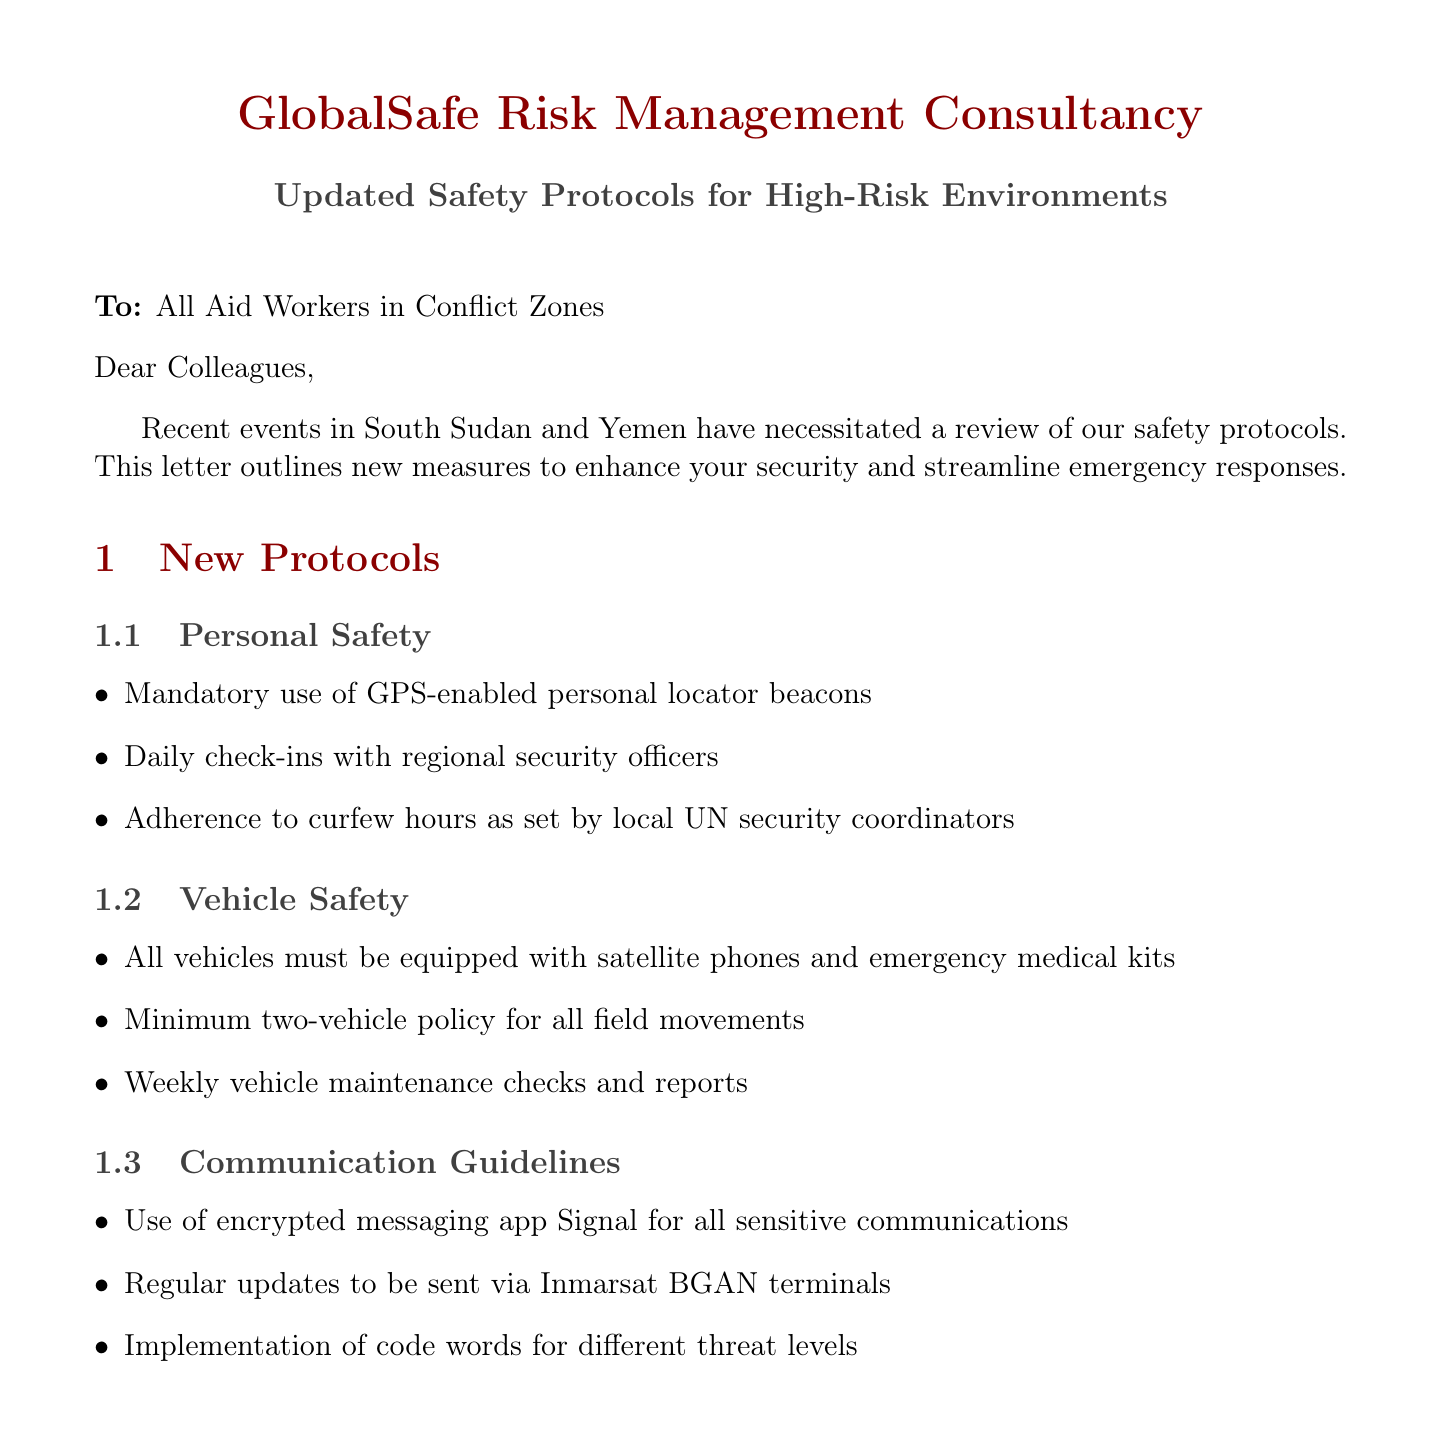What is the sender's name? The sender's name is listed at the top of the document as the organization responsible for the letter.
Answer: GlobalSafe Risk Management Consultancy What is the subject of the letter? The subject line summarizes the main topic covered in the letter.
Answer: Updated Safety Protocols for High-Risk Environments What training is mandatory for aid workers? The mandatory training section lists required training for safety protocols in conflict zones.
Answer: HEAT certification What should be done during a Yellow Alert? The actions required during a Yellow Alert are detailed in the evacuation procedures.
Answer: Prepare grab bags What is the emergency hotline number? The document provides a dedicated emergency contact number for immediate assistance.
Answer: +44 20 7123 4567 Who is the local liaison in Yemen? The document includes contact information for local liaisons in conflict regions.
Answer: Fatima Al-Sayed What communication app should be used for sensitive communications? The communication guidelines specify a particular app for secure interactions.
Answer: Signal What is the date of the virtual briefing session? The conclusion section mentions a specific date for an upcoming information session.
Answer: May 15th What is required before all field movements? The vehicle safety protocols specify a rule to ensure that movements are made safely.
Answer: Minimum two-vehicle policy 